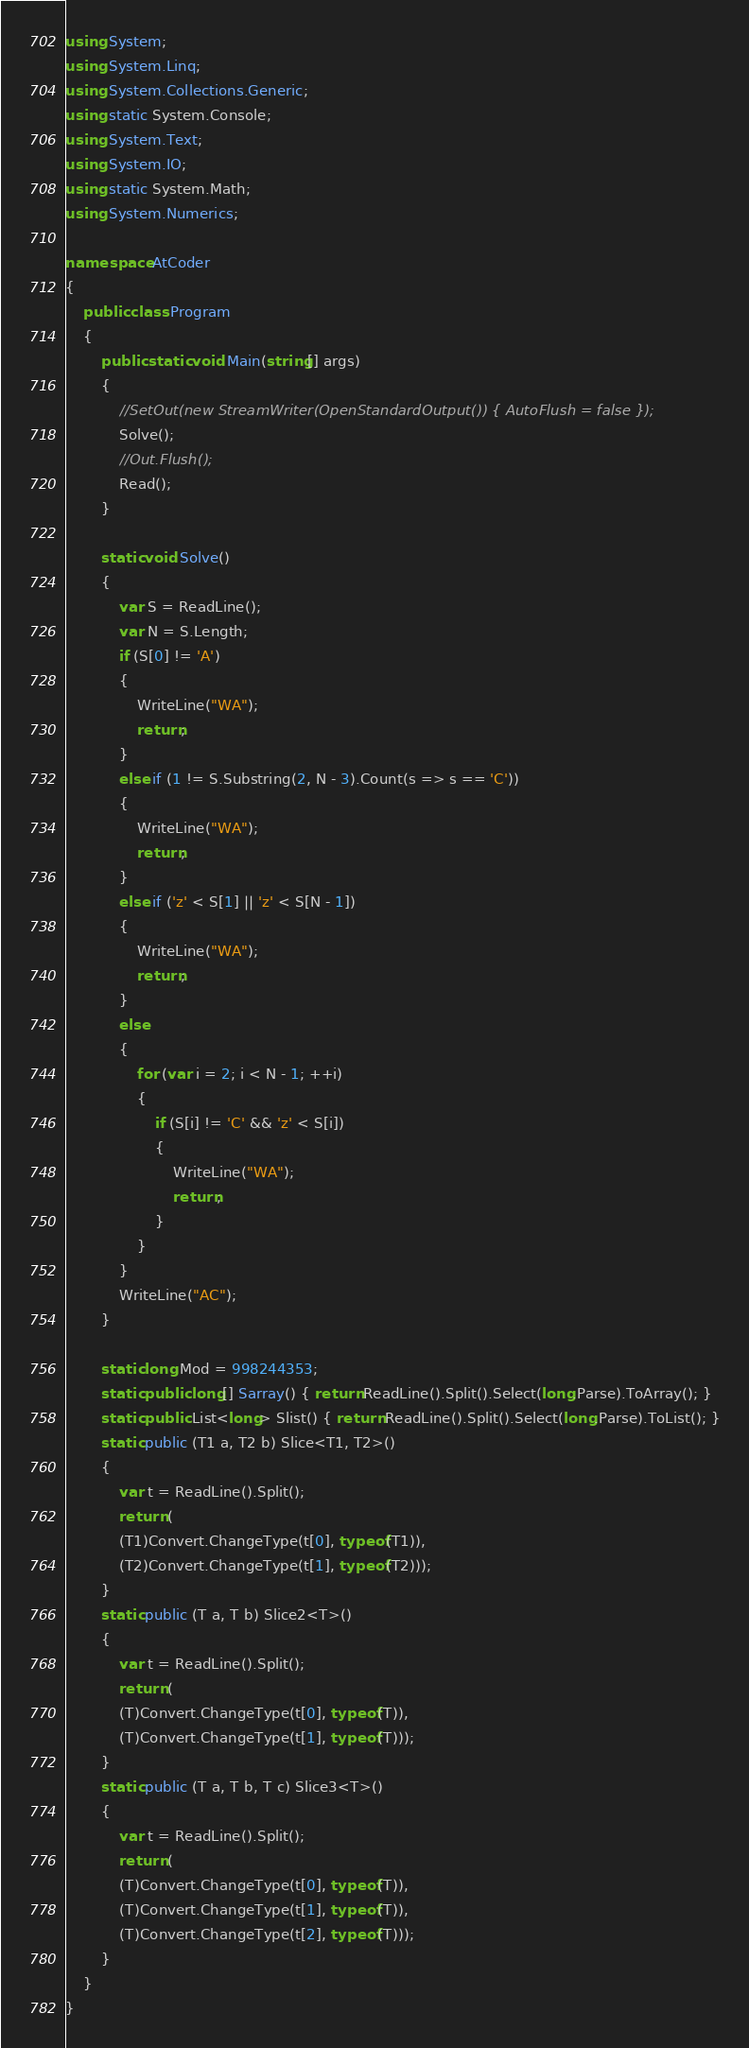<code> <loc_0><loc_0><loc_500><loc_500><_C#_>using System;
using System.Linq;
using System.Collections.Generic;
using static System.Console;
using System.Text;
using System.IO;
using static System.Math;
using System.Numerics;

namespace AtCoder
{
    public class Program
    {
        public static void Main(string[] args)
        {
            //SetOut(new StreamWriter(OpenStandardOutput()) { AutoFlush = false });
            Solve();
            //Out.Flush();
            Read();
        }

        static void Solve()
        {
            var S = ReadLine();
            var N = S.Length;
            if (S[0] != 'A')
            {
                WriteLine("WA");
                return;
            }
            else if (1 != S.Substring(2, N - 3).Count(s => s == 'C'))
            {
                WriteLine("WA");
                return;
            }
            else if ('z' < S[1] || 'z' < S[N - 1])
            {
                WriteLine("WA");
                return;
            }
            else
            {
                for (var i = 2; i < N - 1; ++i)
                {
                    if (S[i] != 'C' && 'z' < S[i])
                    {
                        WriteLine("WA");
                        return;
                    }
                }
            }
            WriteLine("AC");
        }

        static long Mod = 998244353;
        static public long[] Sarray() { return ReadLine().Split().Select(long.Parse).ToArray(); }
        static public List<long> Slist() { return ReadLine().Split().Select(long.Parse).ToList(); }
        static public (T1 a, T2 b) Slice<T1, T2>()
        {
            var t = ReadLine().Split();
            return (
            (T1)Convert.ChangeType(t[0], typeof(T1)),
            (T2)Convert.ChangeType(t[1], typeof(T2)));
        }
        static public (T a, T b) Slice2<T>()
        {
            var t = ReadLine().Split();
            return (
            (T)Convert.ChangeType(t[0], typeof(T)),
            (T)Convert.ChangeType(t[1], typeof(T)));
        }
        static public (T a, T b, T c) Slice3<T>()
        {
            var t = ReadLine().Split();
            return (
            (T)Convert.ChangeType(t[0], typeof(T)),
            (T)Convert.ChangeType(t[1], typeof(T)),
            (T)Convert.ChangeType(t[2], typeof(T)));
        }
    }
}</code> 